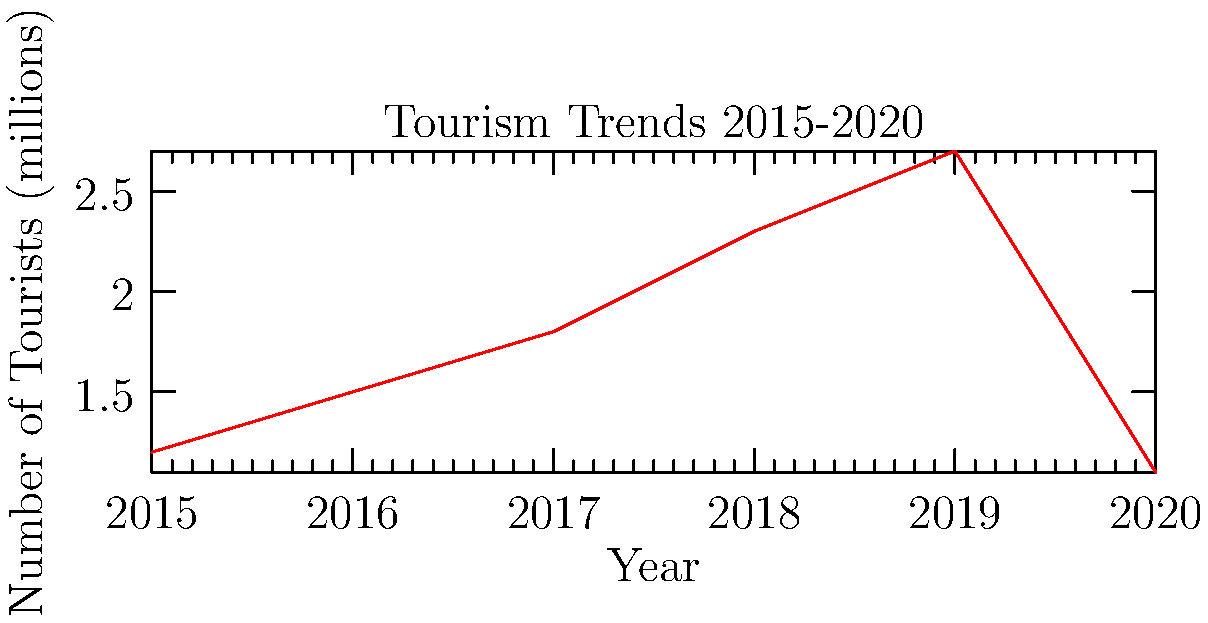As a hotel developer analyzing tourism trends, what was the percentage decrease in tourist numbers from 2019 to 2020, and how might this impact your investment strategy in emerging markets? To answer this question, we need to follow these steps:

1. Identify the number of tourists in 2019 and 2020:
   2019: 2.7 million tourists
   2020: 1.1 million tourists

2. Calculate the percentage decrease:
   Decrease = (Old value - New value) / Old value * 100
   = (2.7 - 1.1) / 2.7 * 100
   = 1.6 / 2.7 * 100
   ≈ 59.26%

3. Impact on investment strategy:
   a) The sharp decline (about 59%) indicates a significant disruption in the tourism industry, likely due to the COVID-19 pandemic.
   b) Short-term: Be cautious about new investments, focus on cost-cutting and maintaining existing properties.
   c) Long-term: Look for opportunities in markets that are expected to recover quickly post-pandemic.
   d) Consider diversifying investments across different types of properties (e.g., business hotels, extended stay) to mitigate risks.
   e) Explore emerging markets that may have been less affected or are showing signs of faster recovery.
   f) Invest in properties that can be easily adapted to changing travel trends (e.g., remote work-friendly amenities).
Answer: 59% decrease; Caution in short-term, seek opportunities in recovering markets long-term 